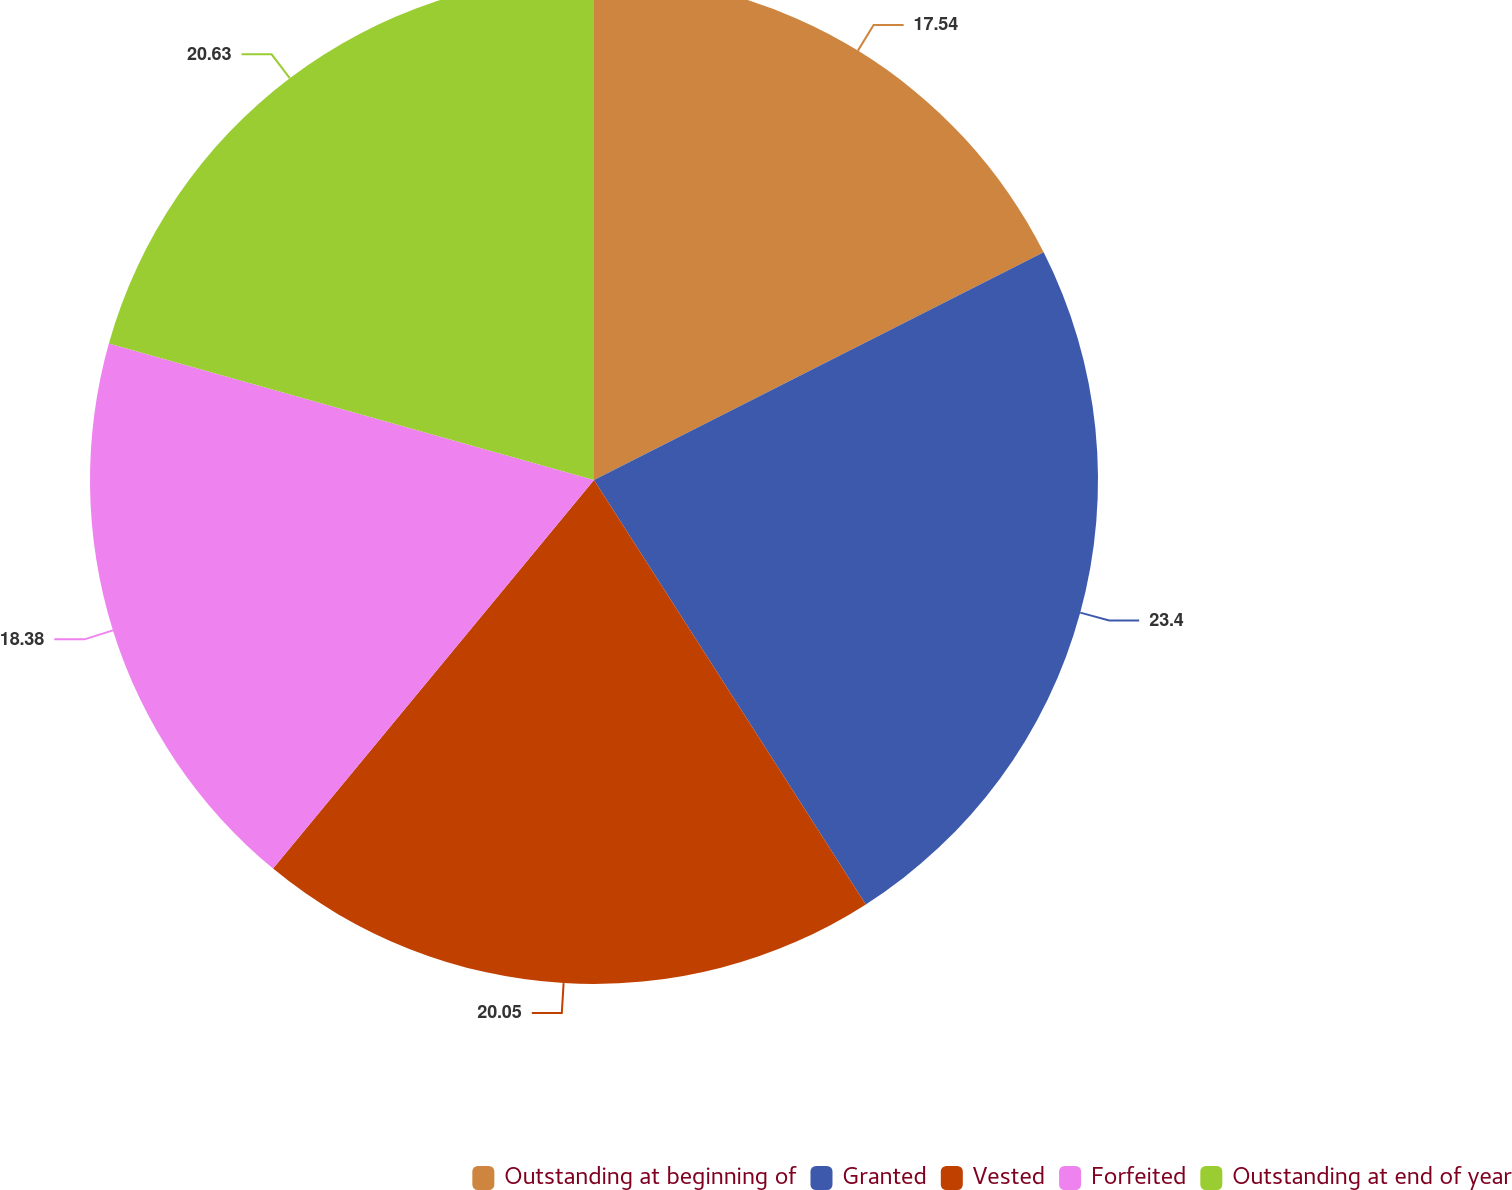<chart> <loc_0><loc_0><loc_500><loc_500><pie_chart><fcel>Outstanding at beginning of<fcel>Granted<fcel>Vested<fcel>Forfeited<fcel>Outstanding at end of year<nl><fcel>17.54%<fcel>23.39%<fcel>20.05%<fcel>18.38%<fcel>20.63%<nl></chart> 